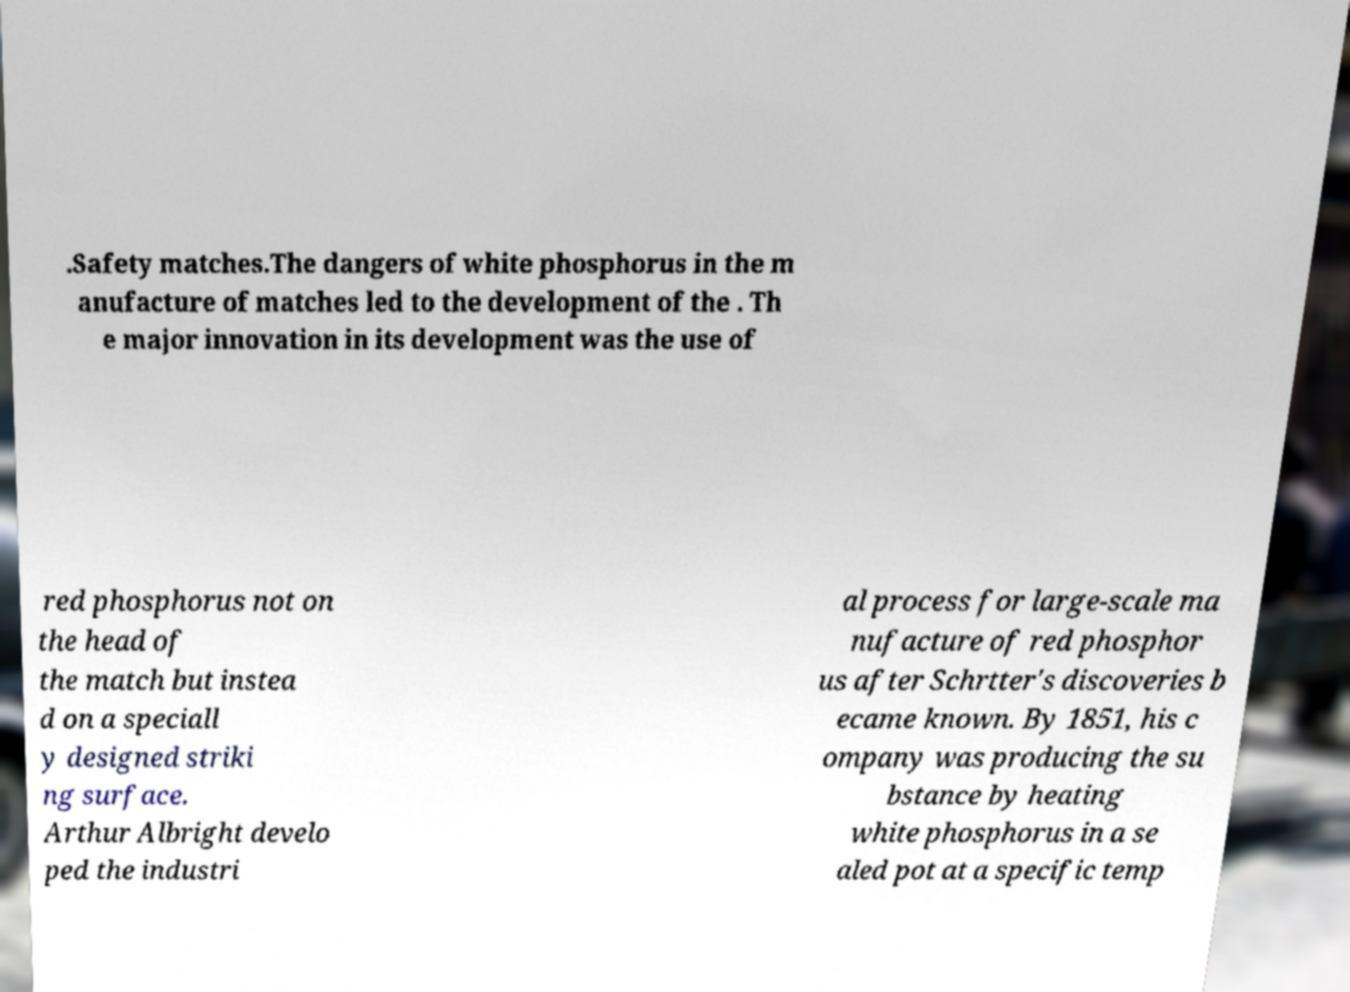Can you read and provide the text displayed in the image?This photo seems to have some interesting text. Can you extract and type it out for me? .Safety matches.The dangers of white phosphorus in the m anufacture of matches led to the development of the . Th e major innovation in its development was the use of red phosphorus not on the head of the match but instea d on a speciall y designed striki ng surface. Arthur Albright develo ped the industri al process for large-scale ma nufacture of red phosphor us after Schrtter's discoveries b ecame known. By 1851, his c ompany was producing the su bstance by heating white phosphorus in a se aled pot at a specific temp 